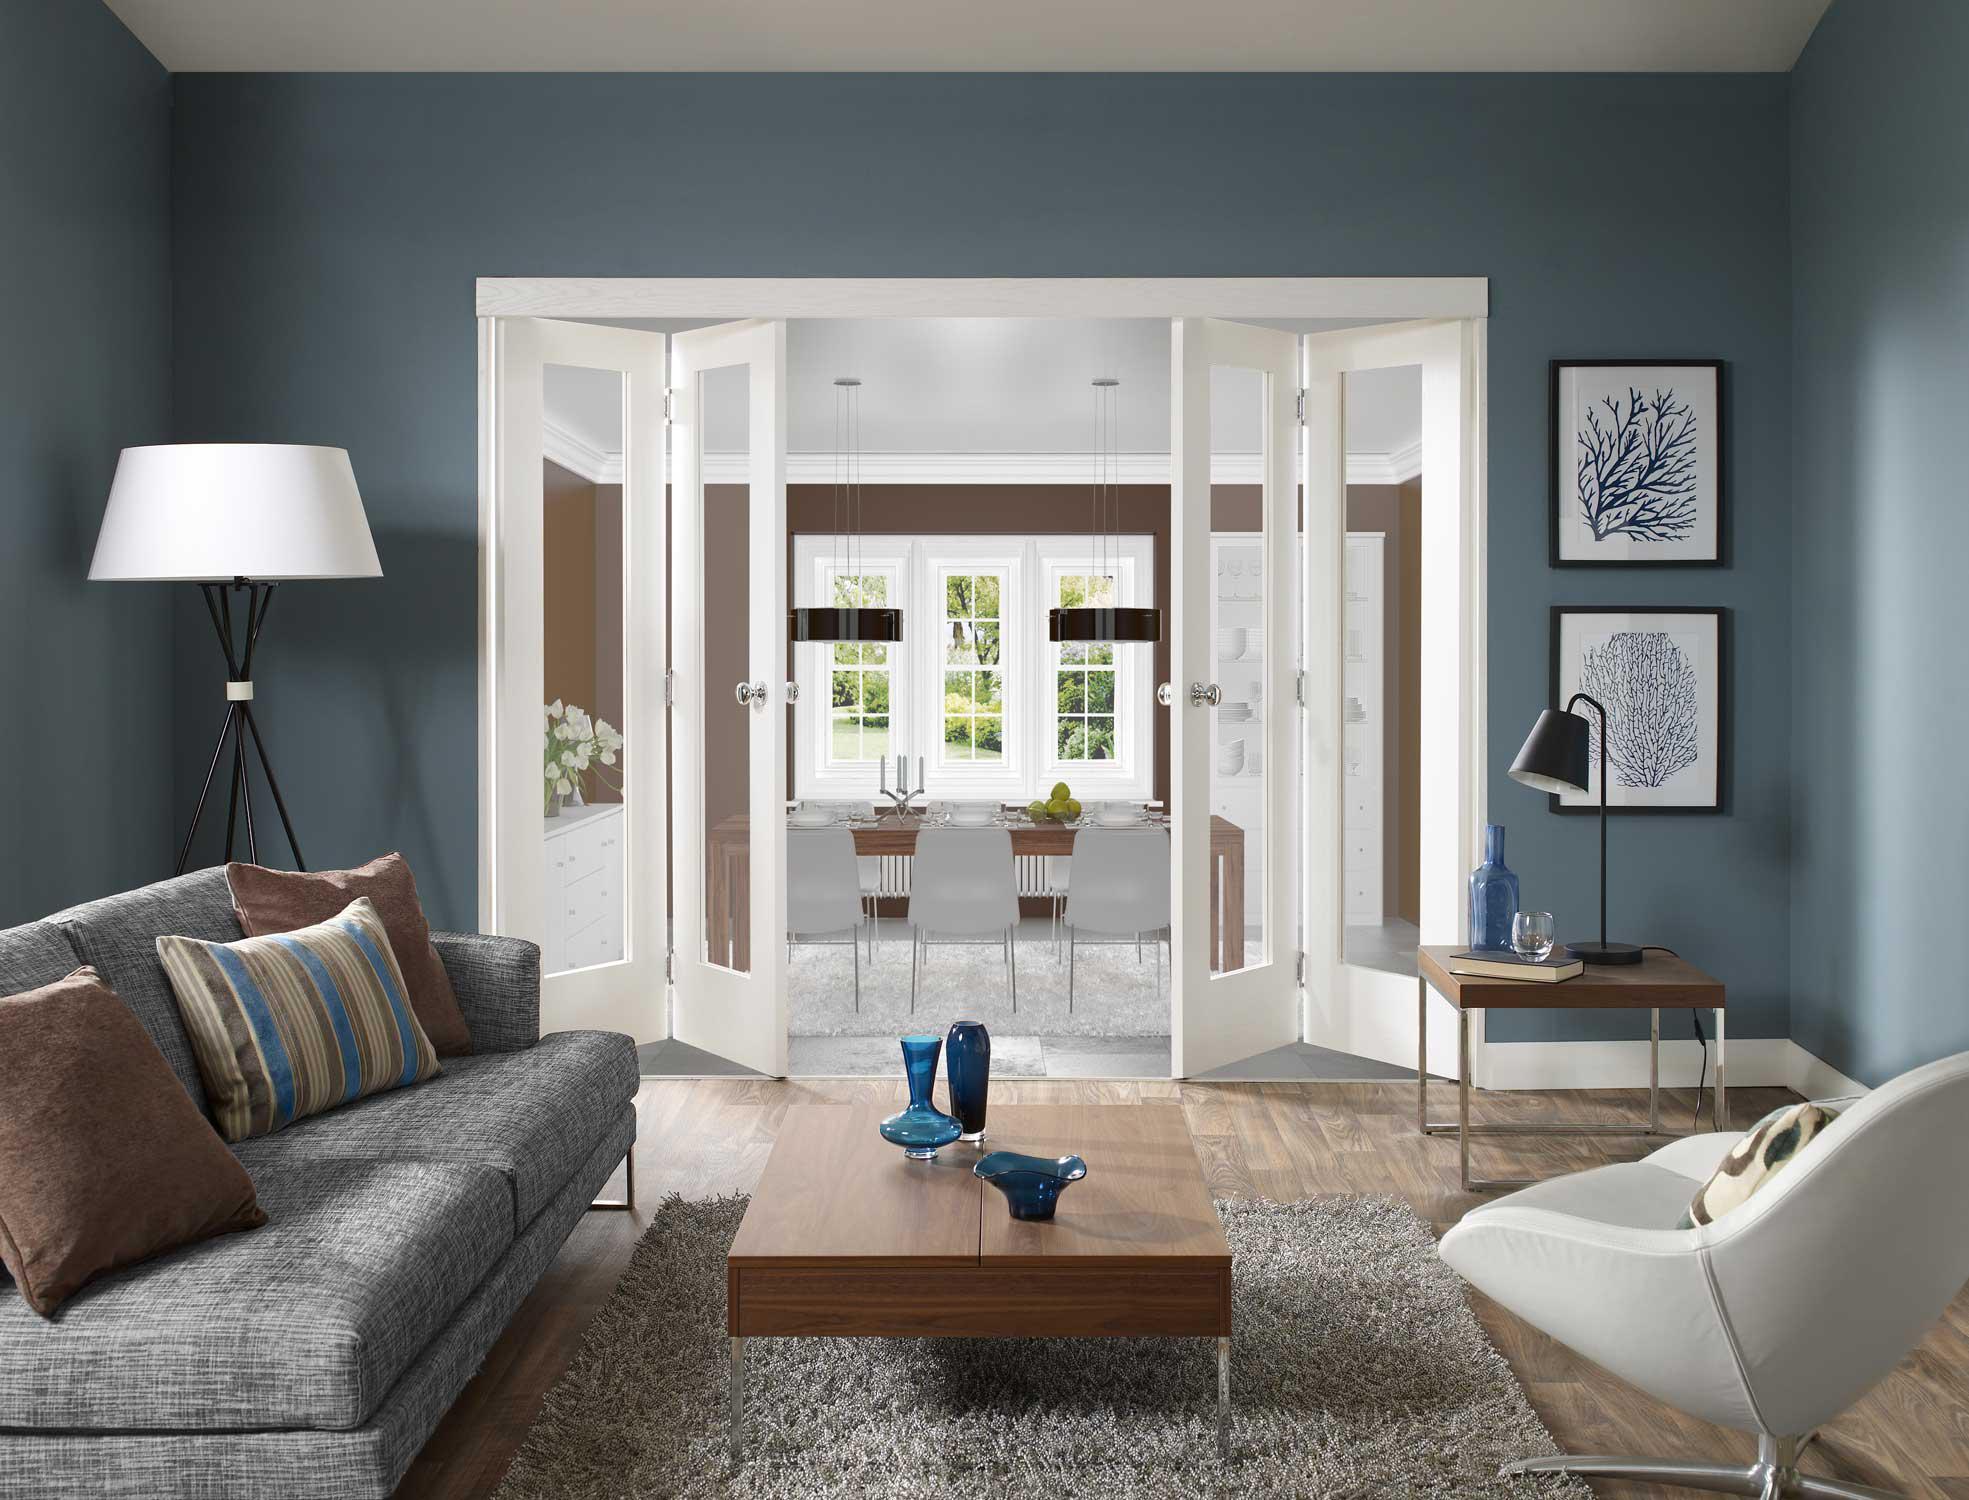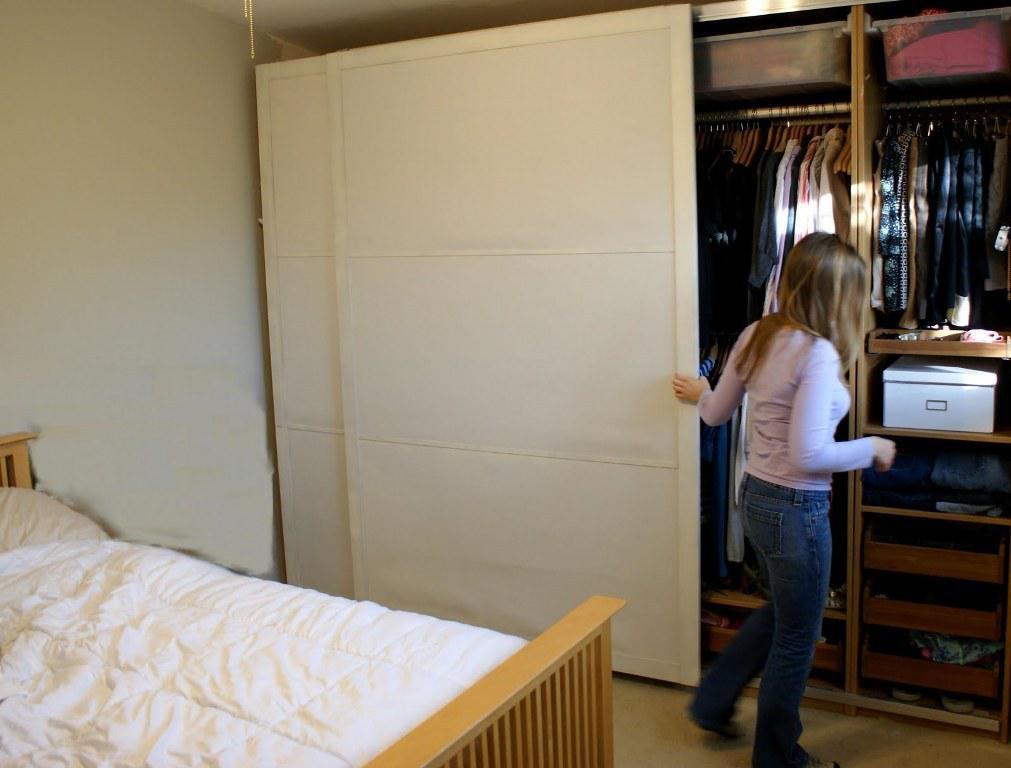The first image is the image on the left, the second image is the image on the right. Given the left and right images, does the statement "In at least one image there is an open white and glass panel door that shows chairs behind it." hold true? Answer yes or no. Yes. 